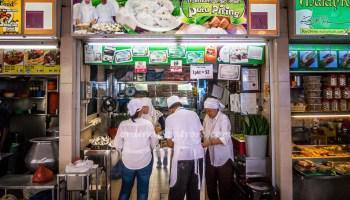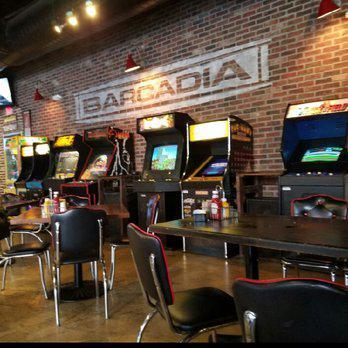The first image is the image on the left, the second image is the image on the right. Analyze the images presented: Is the assertion "There is an employee of the business in one of the images." valid? Answer yes or no. Yes. The first image is the image on the left, the second image is the image on the right. Given the left and right images, does the statement "The right image shows tables and chairs for patrons, and the left image shows multiple people with backs to the camera in the foreground." hold true? Answer yes or no. Yes. 